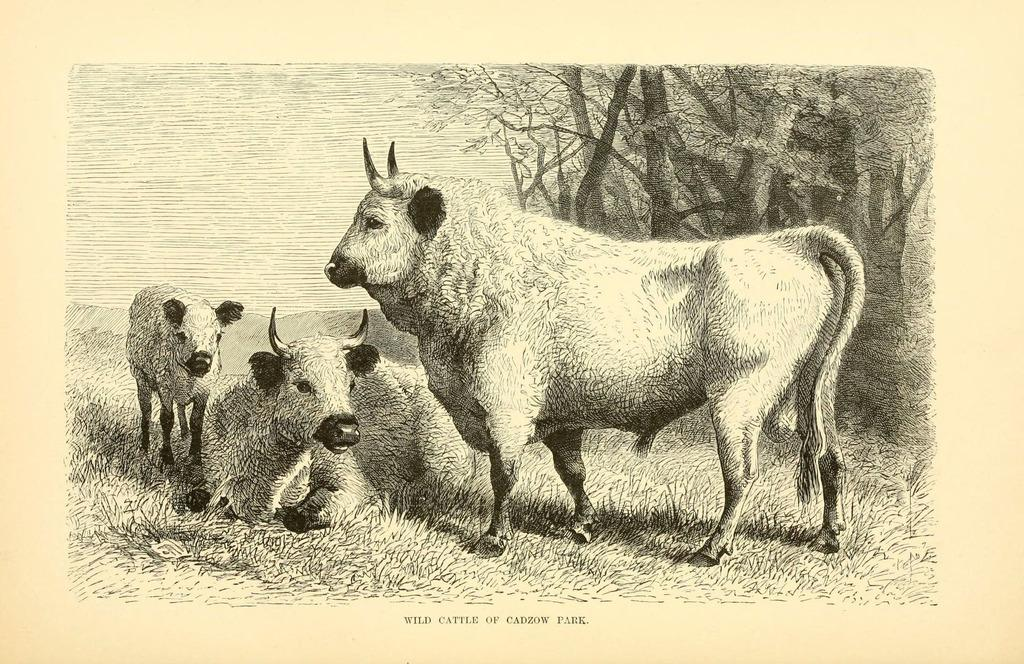What types of living organisms can be seen in the image? The image contains animals. What can be seen in the background of the image? There are trees in the image. What is visible in the foreground of the image? There is water in the image. What type of honey can be seen dripping from the trees in the image? There is no honey present in the image, and no honey is dripping from the trees. 